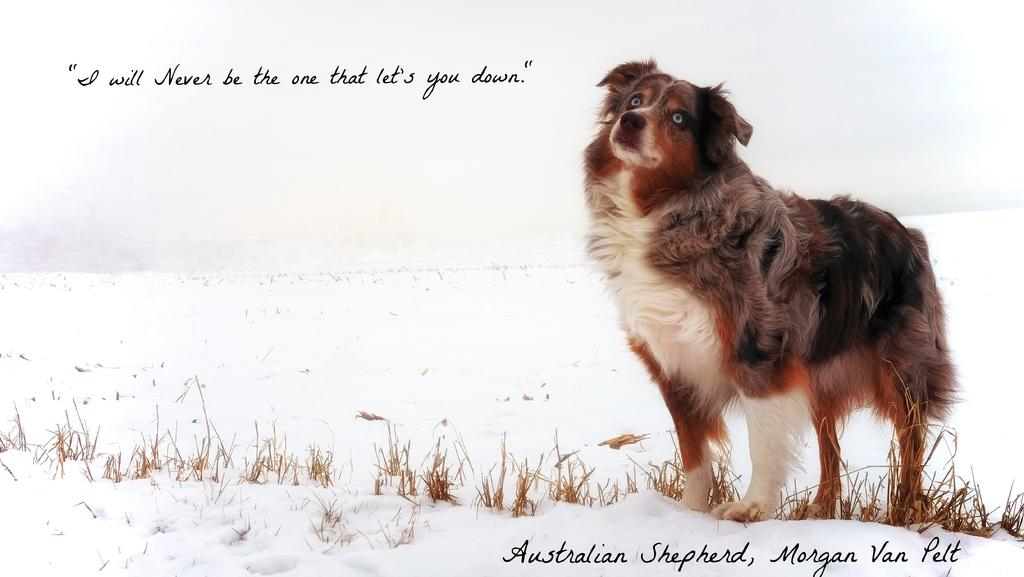What animal is present in the image? There is a dog in the image. What surface is the dog standing on? The dog is standing on the snow. Has the image been altered in any way? Yes, the image has been edited. What additional text can be found in the image? There is a quotation written above the picture and another one written below the picture. What type of fear does the dog exhibit in the image? There is no indication of fear in the image; the dog is simply standing on the snow. How many pets are visible in the image? There is only one pet visible in the image, which is the dog. 